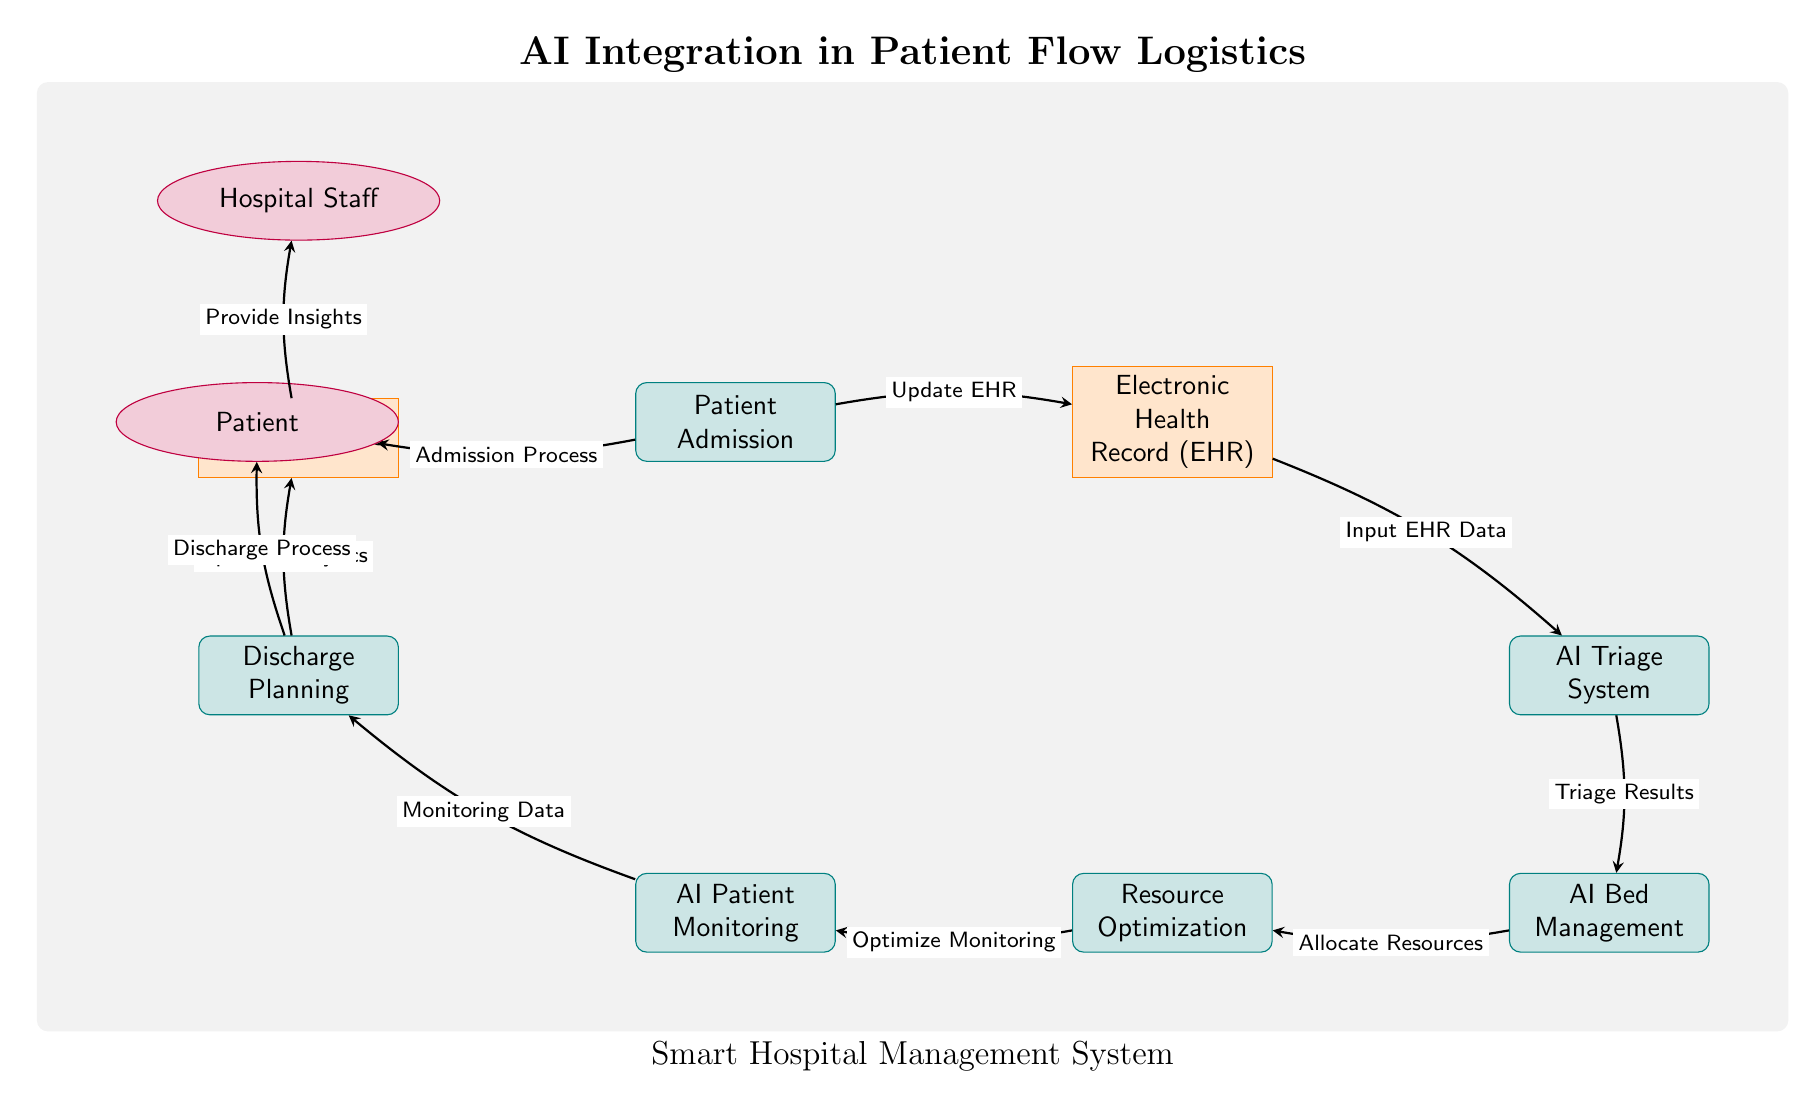What is the first process listed in the diagram? The first process in the diagram is labeled "Patient Admission." This can be found at the top left corner, indicating it is the starting point of the patient flow logistics.
Answer: Patient Admission How many processes are displayed in the diagram? The diagram shows six processes: Patient Admission, AI Triage System, AI Bed Management, Resource Optimization, AI Patient Monitoring, and Discharge Planning. Counting these nodes yields a total of six processes.
Answer: 6 What type of data is associated with the Electronic Health Record? The Electronic Health Record is associated with the input of EHR data, as indicated by the directed arrow connecting EHR to AI Triage System. This suggests that the EHR serves as crucial data for patient analysis and triaging decisions.
Answer: Input EHR Data What is the purpose of the arrow between AI Bed Management and Resource Optimization? The arrow indicates "Allocate Resources," which describes the action directed from AI Bed Management to Resource Optimization, demonstrating the flow of resource allocation based on bed management decisions.
Answer: Allocate Resources Which entity provides insights based on the analytics data? The Hospital Staff is identified as the entity that receives the insights derived from the analytics, as shown by the arrow that connects Data Analytics to Hospital Staff. This highlights their role in utilizing data for improving patient management.
Answer: Hospital Staff What is the final outcome for the patient flow in the diagram? The final outcome is Discharge Process, which communicates the completion of patient care and their transition out of the hospital system, emphasizing the end of the entire flow presented in the diagram.
Answer: Discharge Process What do the arrows represent in the context of the diagram? The arrows represent the directional flow of information and processes between nodes, facilitating the understanding of how patient data and management steps move through the smart hospital system. This illustrates the interconnected processes in patient flow logistics.
Answer: Flow of information What process comes after AI Triage System in the patient flow? The process that follows AI Triage System is AI Bed Management, as shown by the arrow pointing down from the triage system to the bed management node, indicating the sequential progression in patient handling.
Answer: AI Bed Management What role does Data Analytics play in the discharge planning process? Data Analytics is critical as it updates the insights which assist the Hospital Staff in making informed decisions regarding Discharge Planning, showing its importance in enhancing the efficiency of the discharge process.
Answer: Update Analytics 